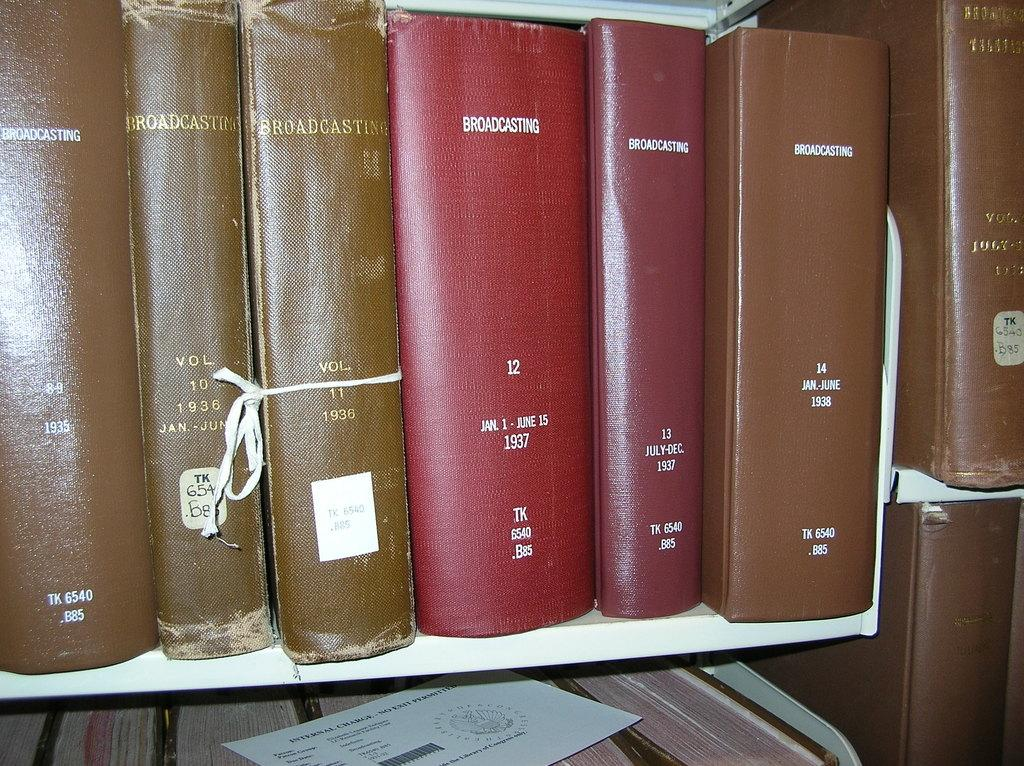Provide a one-sentence caption for the provided image. a row of books with one of them titled 'broadcasting'. 